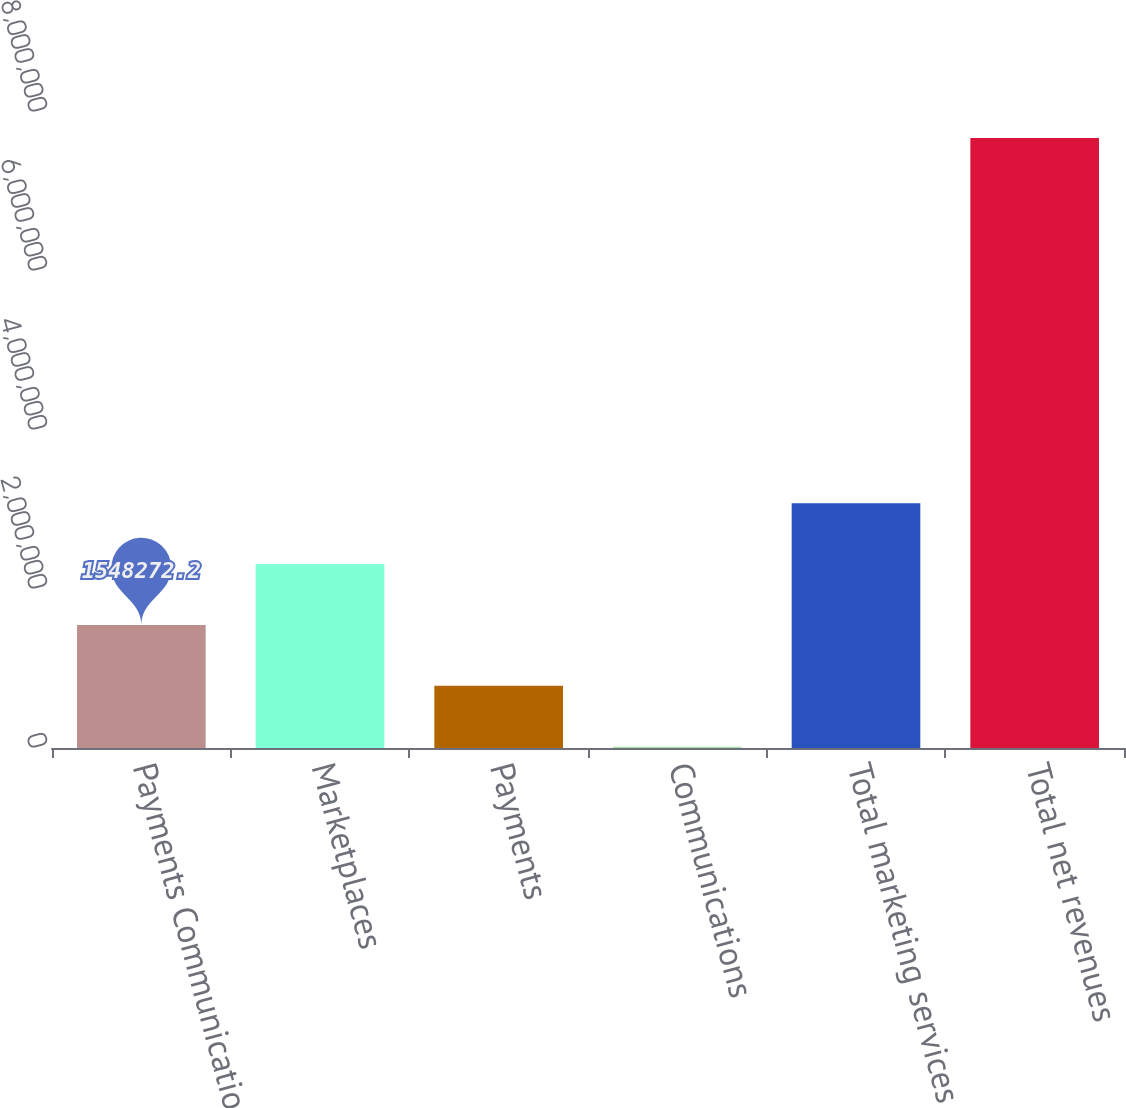Convert chart to OTSL. <chart><loc_0><loc_0><loc_500><loc_500><bar_chart><fcel>Payments Communications<fcel>Marketplaces<fcel>Payments<fcel>Communications<fcel>Total marketing services and<fcel>Total net revenues<nl><fcel>1.54827e+06<fcel>2.31378e+06<fcel>782765<fcel>17258<fcel>3.07929e+06<fcel>7.67233e+06<nl></chart> 